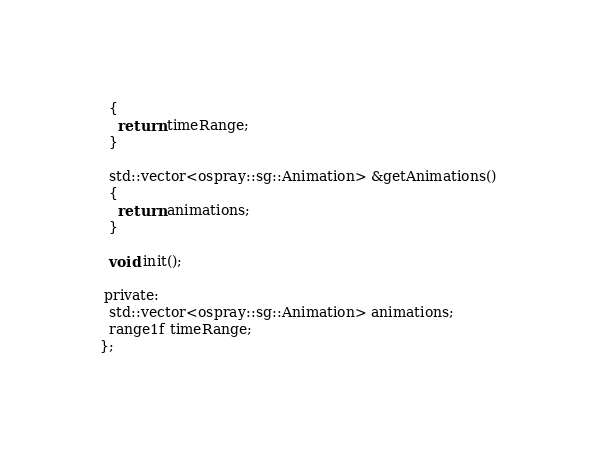<code> <loc_0><loc_0><loc_500><loc_500><_C_>  {
    return timeRange;
  }

  std::vector<ospray::sg::Animation> &getAnimations()
  {
    return animations;
  }

  void init();

 private:
  std::vector<ospray::sg::Animation> animations;
  range1f timeRange;
};
</code> 